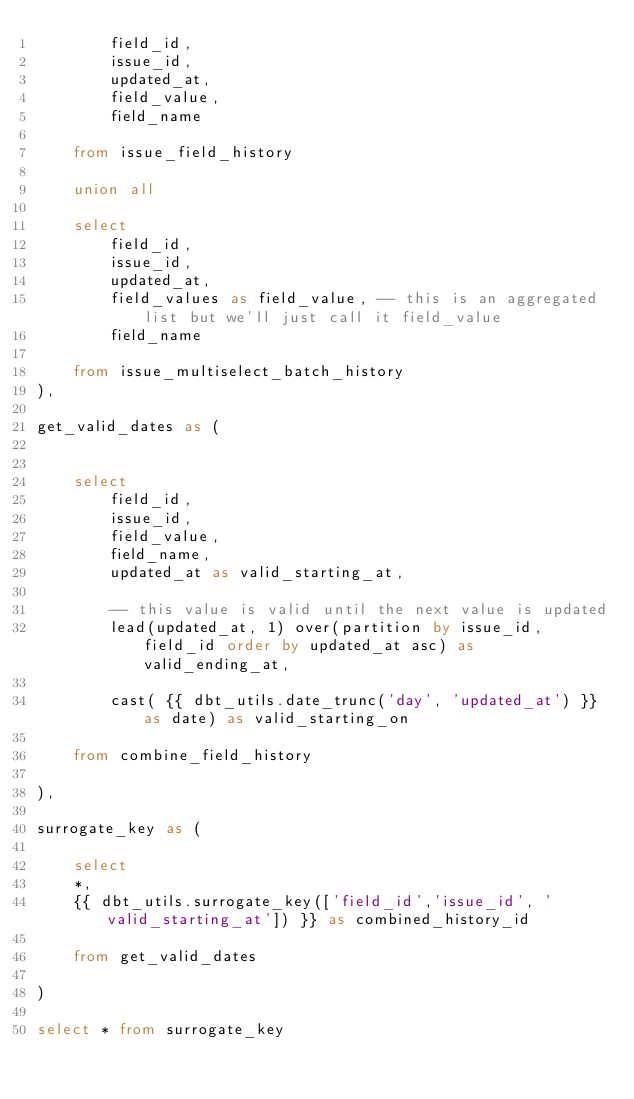<code> <loc_0><loc_0><loc_500><loc_500><_SQL_>        field_id,
        issue_id,
        updated_at,
        field_value,
        field_name

    from issue_field_history

    union all

    select 
        field_id,
        issue_id,
        updated_at,
        field_values as field_value, -- this is an aggregated list but we'll just call it field_value
        field_name

    from issue_multiselect_batch_history
),

get_valid_dates as (


    select 
        field_id,
        issue_id,
        field_value,
        field_name,
        updated_at as valid_starting_at,

        -- this value is valid until the next value is updated
        lead(updated_at, 1) over(partition by issue_id, field_id order by updated_at asc) as valid_ending_at, 

        cast( {{ dbt_utils.date_trunc('day', 'updated_at') }} as date) as valid_starting_on

    from combine_field_history

),

surrogate_key as (

    select 
    *,
    {{ dbt_utils.surrogate_key(['field_id','issue_id', 'valid_starting_at']) }} as combined_history_id

    from get_valid_dates

)

select * from surrogate_key</code> 